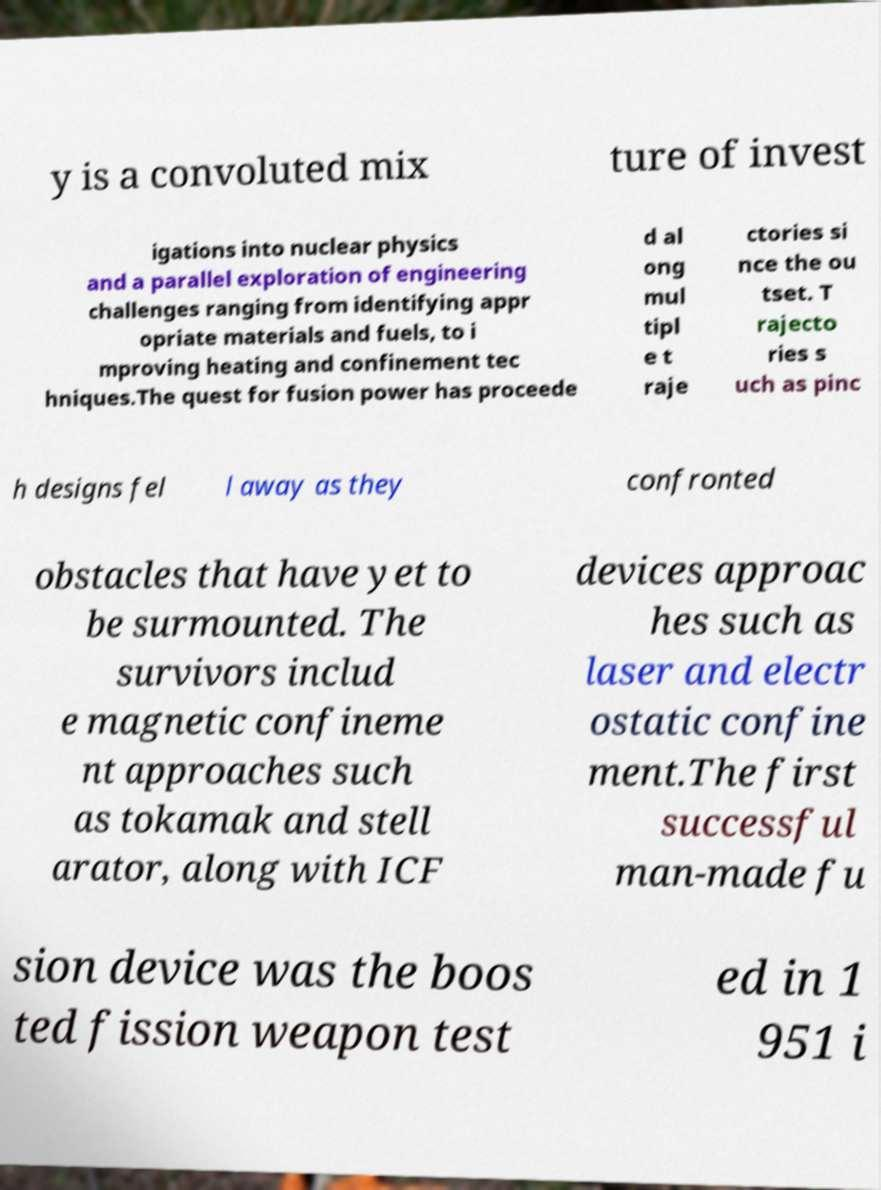Could you assist in decoding the text presented in this image and type it out clearly? y is a convoluted mix ture of invest igations into nuclear physics and a parallel exploration of engineering challenges ranging from identifying appr opriate materials and fuels, to i mproving heating and confinement tec hniques.The quest for fusion power has proceede d al ong mul tipl e t raje ctories si nce the ou tset. T rajecto ries s uch as pinc h designs fel l away as they confronted obstacles that have yet to be surmounted. The survivors includ e magnetic confineme nt approaches such as tokamak and stell arator, along with ICF devices approac hes such as laser and electr ostatic confine ment.The first successful man-made fu sion device was the boos ted fission weapon test ed in 1 951 i 